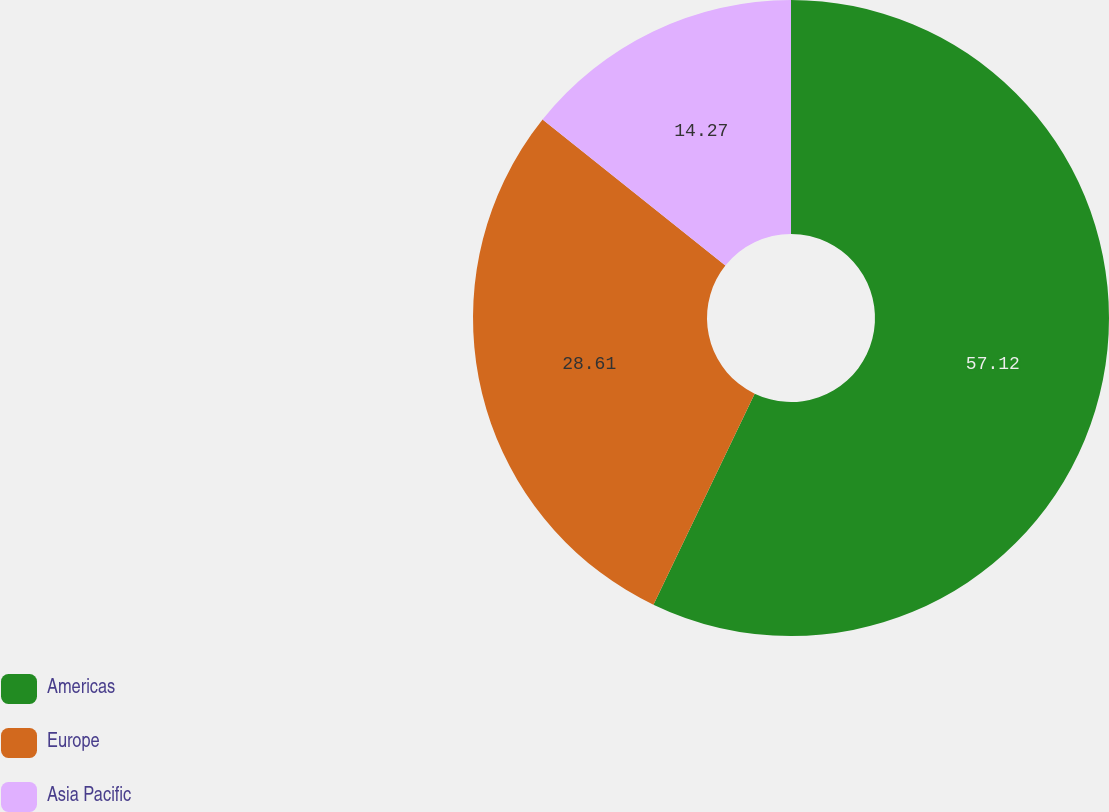<chart> <loc_0><loc_0><loc_500><loc_500><pie_chart><fcel>Americas<fcel>Europe<fcel>Asia Pacific<nl><fcel>57.12%<fcel>28.61%<fcel>14.27%<nl></chart> 